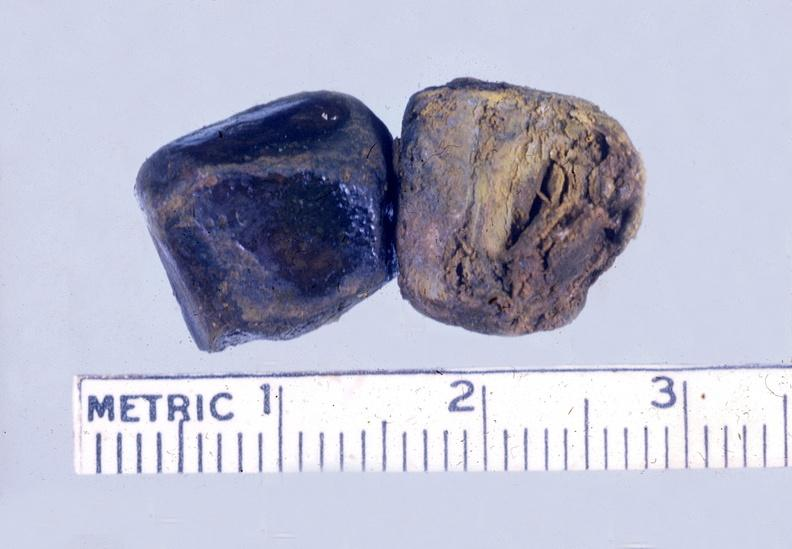s laceration present?
Answer the question using a single word or phrase. No 